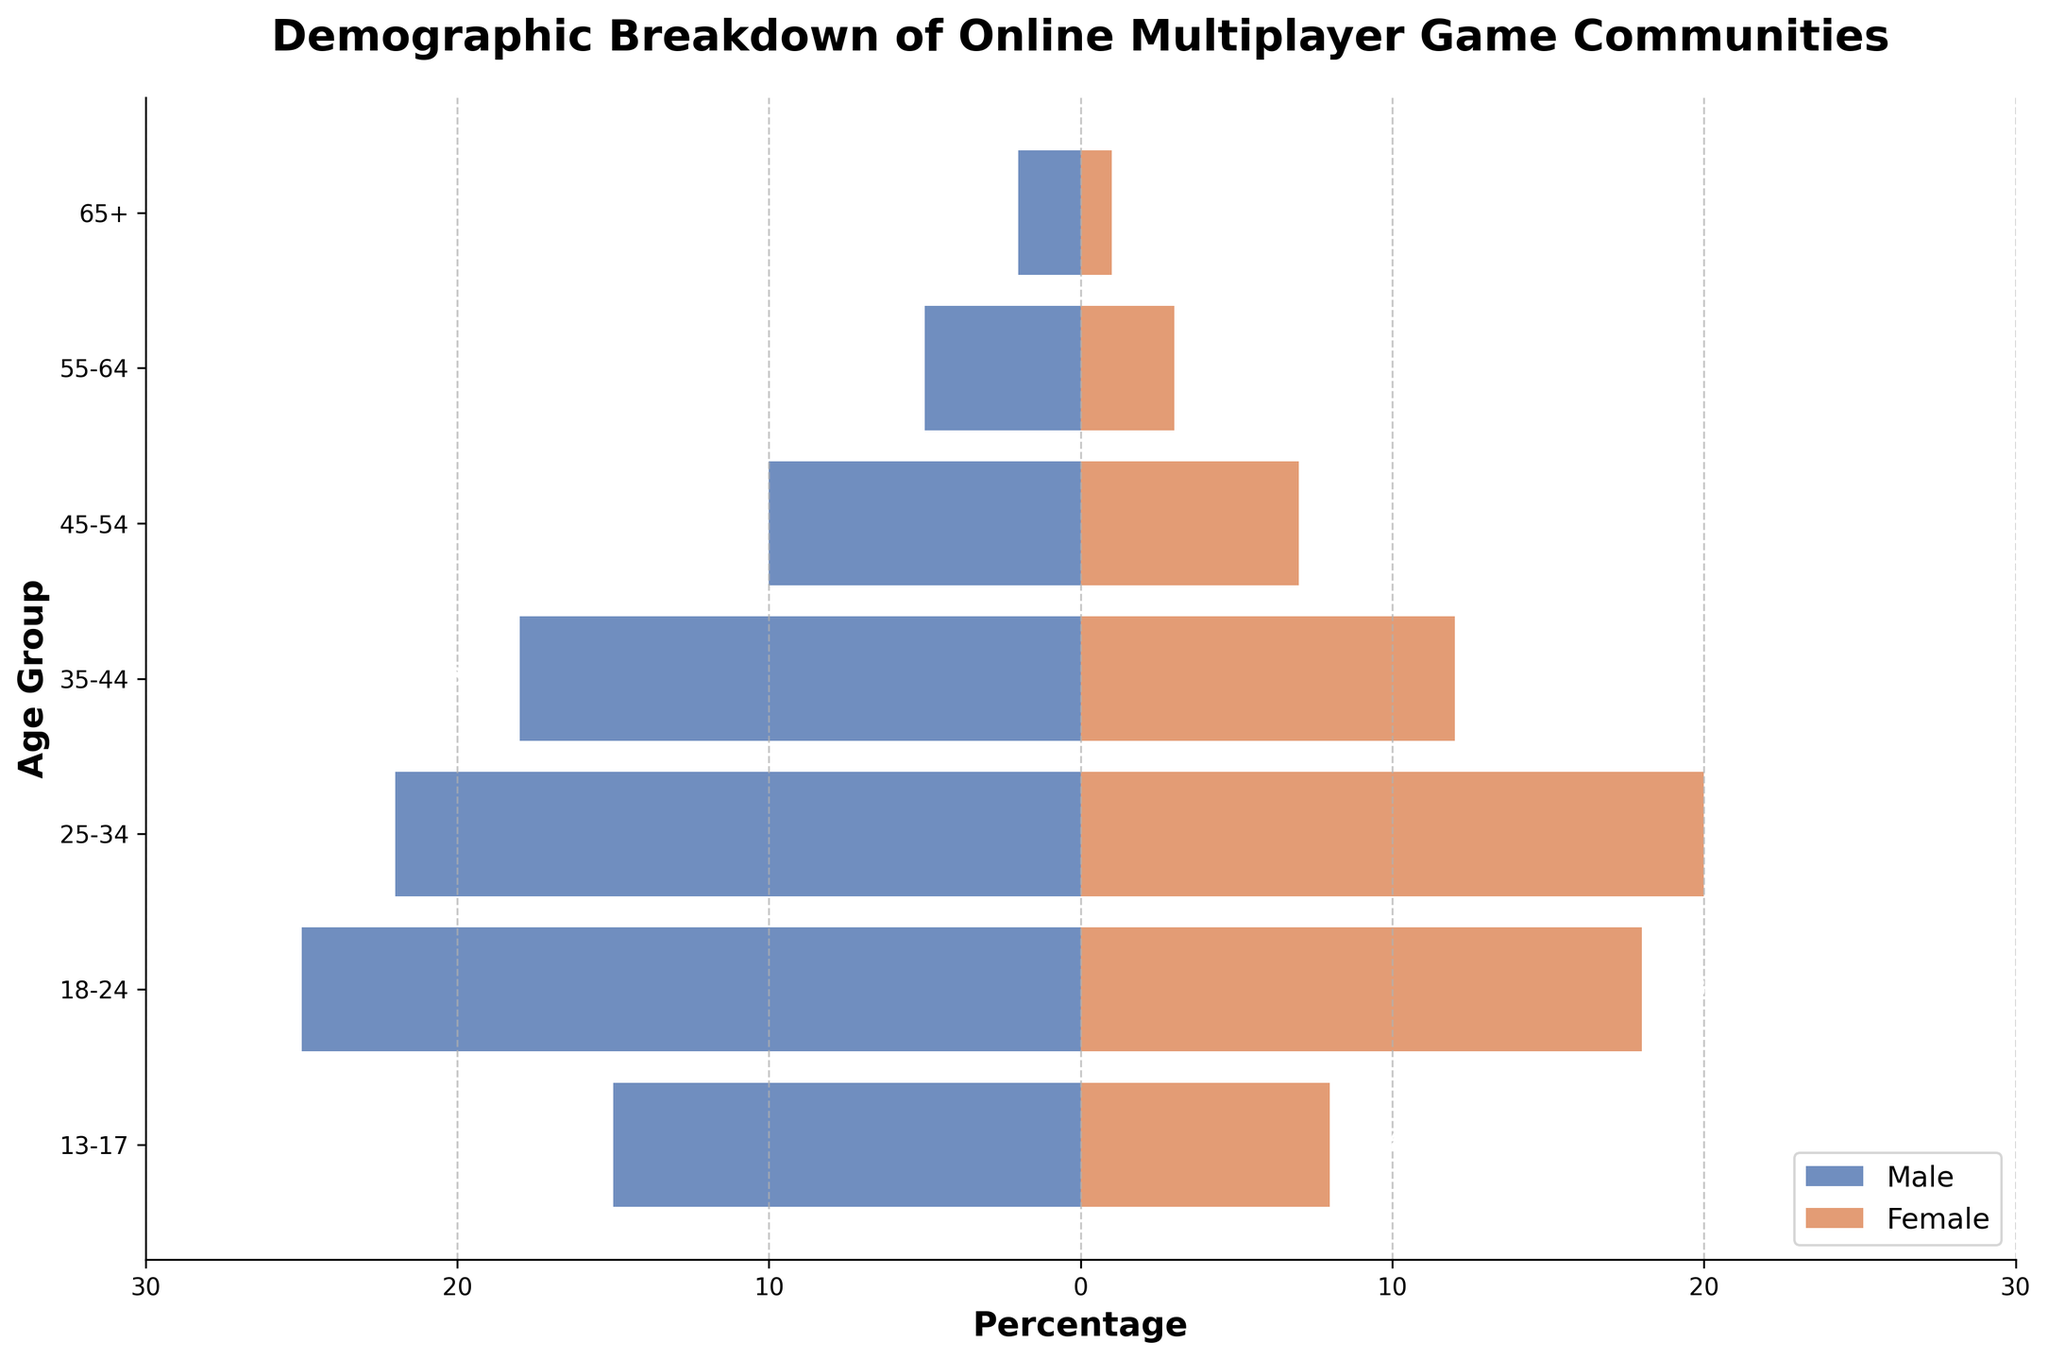Which age group has the highest percentage of male players? By observing the figure, we see that the 18-24 age group has the longest bar on the left (male side), indicating the highest percentage.
Answer: 18-24 How many more male players are there compared to female players in the 45-54 age group? The percentage of male players is 10% and female players are 7% in this age group. The difference is 10% - 7% = 3%.
Answer: 3% What is the total percentage of players in the age group 25-34? The percentages for males and females in the 25-34 age group are 22% and 20%, respectively. The total percentage is 22% + 20% = 42%.
Answer: 42% Which gender has more players in the 55-64 age group? By comparing the lengths of the bars, males have 5% and females have 3% in this age group. Males have a higher percentage.
Answer: Male What is the title of the figure? The title is located at the top of the figure, and it reads 'Demographic Breakdown of Online Multiplayer Game Communities'.
Answer: Demographic Breakdown of Online Multiplayer Game Communities By how much does the percentage of male players decrease from the 18-24 age group to the 35-44 age group? In the 18-24 age group, the percentage is 25%, and in the 35-44 age group, it is 18%. The decrease is 25% - 18% = 7%.
Answer: 7% What’s the least represented age group for female players? By viewing the right side (female side) of the pyramid, the shortest bar is in the '65+' age group with 1%.
Answer: 65+ How do the percentages of male and female players compare in the 13-17 age group? The percentages for males and females in the 13-17 age group are 15% and 8%, respectively. Males have a higher percentage by 15% - 8% = 7%.
Answer: Males are higher by 7% What is the average percentage of male players in the age groups from 35-44 to 65+? The percentages for males in these age groups are 18%, 10%, 5%, and 2%. The average is (18% + 10% + 5% + 2%) / 4 = 8.75%.
Answer: 8.75% Which age groups show a decreasing trend in the percentage of female players as age increases? Observing the right side of the pyramid from younger to older groups, it shows a decreasing trend in the percentages from age 18-24 (18%) through 65+ (1%).
Answer: All 